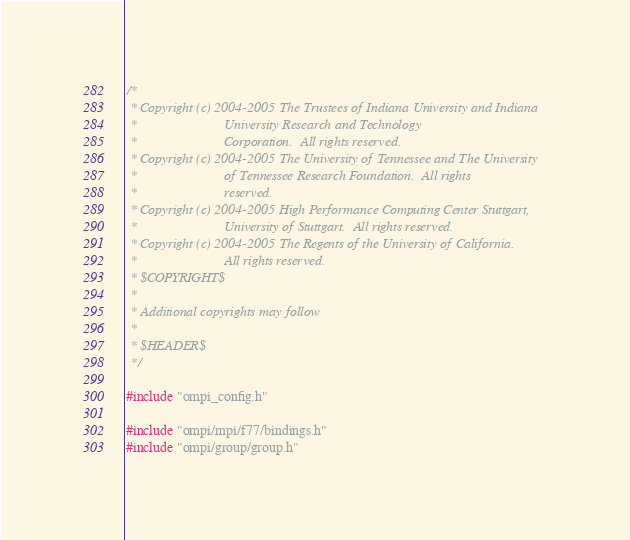<code> <loc_0><loc_0><loc_500><loc_500><_C_>/*
 * Copyright (c) 2004-2005 The Trustees of Indiana University and Indiana
 *                         University Research and Technology
 *                         Corporation.  All rights reserved.
 * Copyright (c) 2004-2005 The University of Tennessee and The University
 *                         of Tennessee Research Foundation.  All rights
 *                         reserved.
 * Copyright (c) 2004-2005 High Performance Computing Center Stuttgart, 
 *                         University of Stuttgart.  All rights reserved.
 * Copyright (c) 2004-2005 The Regents of the University of California.
 *                         All rights reserved.
 * $COPYRIGHT$
 * 
 * Additional copyrights may follow
 * 
 * $HEADER$
 */

#include "ompi_config.h"

#include "ompi/mpi/f77/bindings.h"
#include "ompi/group/group.h"
</code> 